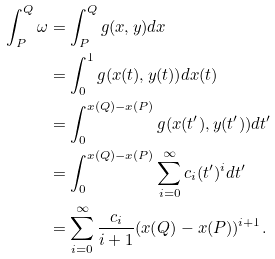<formula> <loc_0><loc_0><loc_500><loc_500>\int _ { P } ^ { Q } \omega & = \int _ { P } ^ { Q } g ( x , y ) d x \\ & = \int _ { 0 } ^ { 1 } g ( x ( t ) , y ( t ) ) d x ( t ) \\ & = \int _ { 0 } ^ { x ( Q ) - x ( P ) } g ( x ( t ^ { \prime } ) , y ( t ^ { \prime } ) ) d t ^ { \prime } \\ & = \int _ { 0 } ^ { x ( Q ) - x ( P ) } \sum _ { i = 0 } ^ { \infty } c _ { i } ( t ^ { \prime } ) ^ { i } d t ^ { \prime } \\ & = \sum _ { i = 0 } ^ { \infty } \frac { c _ { i } } { i + 1 } ( x ( Q ) - x ( P ) ) ^ { i + 1 } .</formula> 